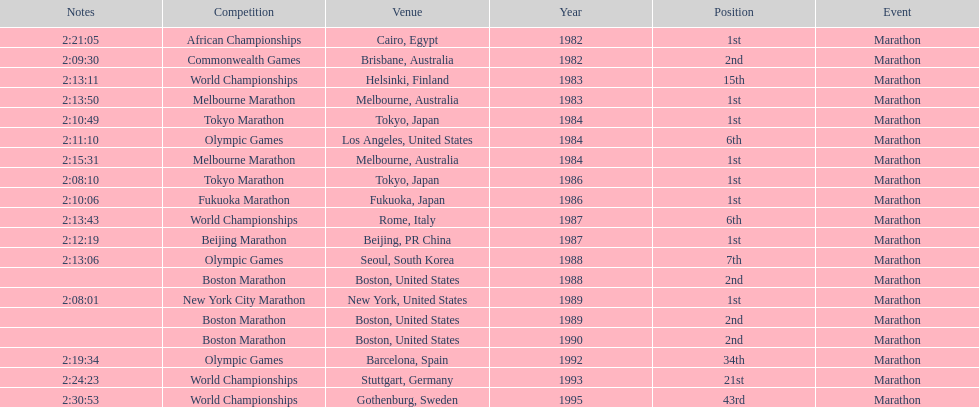In what year did the runner participate in the most marathons? 1984. 